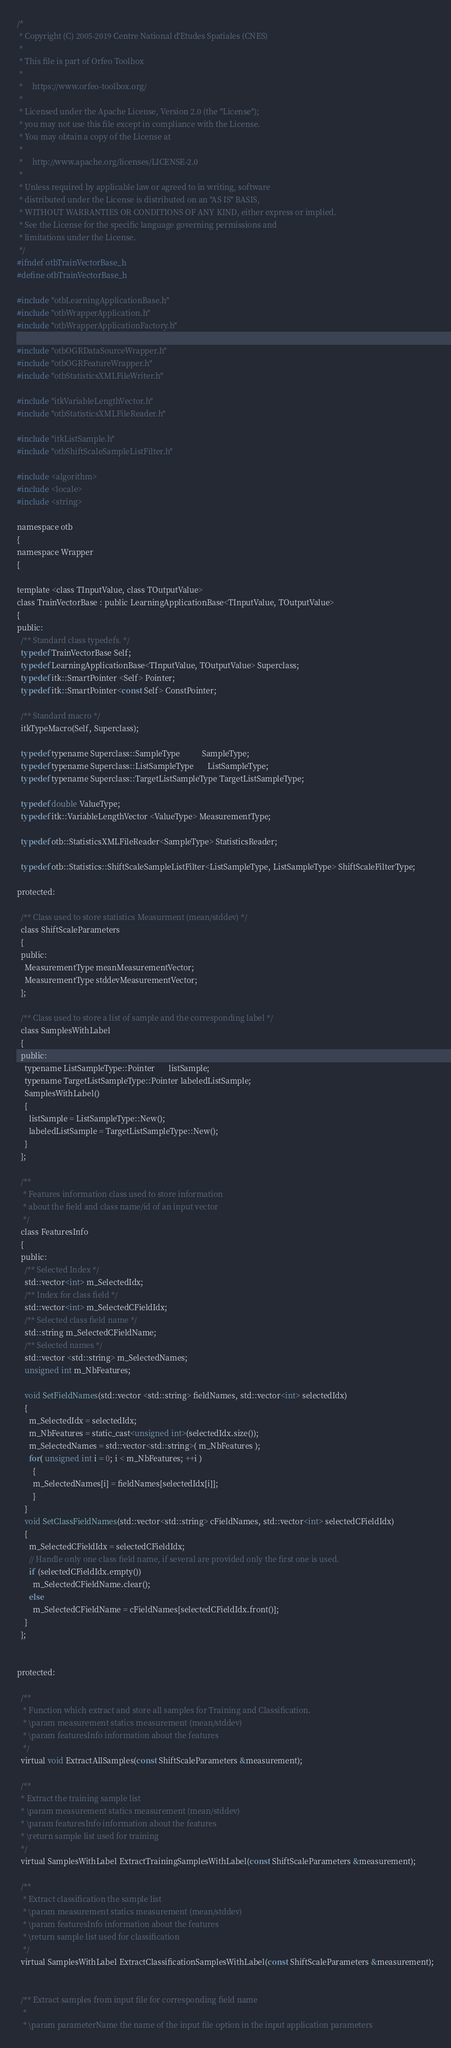Convert code to text. <code><loc_0><loc_0><loc_500><loc_500><_C_>/*
 * Copyright (C) 2005-2019 Centre National d'Etudes Spatiales (CNES)
 *
 * This file is part of Orfeo Toolbox
 *
 *     https://www.orfeo-toolbox.org/
 *
 * Licensed under the Apache License, Version 2.0 (the "License");
 * you may not use this file except in compliance with the License.
 * You may obtain a copy of the License at
 *
 *     http://www.apache.org/licenses/LICENSE-2.0
 *
 * Unless required by applicable law or agreed to in writing, software
 * distributed under the License is distributed on an "AS IS" BASIS,
 * WITHOUT WARRANTIES OR CONDITIONS OF ANY KIND, either express or implied.
 * See the License for the specific language governing permissions and
 * limitations under the License.
 */
#ifndef otbTrainVectorBase_h
#define otbTrainVectorBase_h

#include "otbLearningApplicationBase.h"
#include "otbWrapperApplication.h"
#include "otbWrapperApplicationFactory.h"

#include "otbOGRDataSourceWrapper.h"
#include "otbOGRFeatureWrapper.h"
#include "otbStatisticsXMLFileWriter.h"

#include "itkVariableLengthVector.h"
#include "otbStatisticsXMLFileReader.h"

#include "itkListSample.h"
#include "otbShiftScaleSampleListFilter.h"

#include <algorithm>
#include <locale>
#include <string>

namespace otb
{
namespace Wrapper
{

template <class TInputValue, class TOutputValue>
class TrainVectorBase : public LearningApplicationBase<TInputValue, TOutputValue>
{
public:
  /** Standard class typedefs. */
  typedef TrainVectorBase Self;
  typedef LearningApplicationBase<TInputValue, TOutputValue> Superclass;
  typedef itk::SmartPointer <Self> Pointer;
  typedef itk::SmartPointer<const Self> ConstPointer;

  /** Standard macro */
  itkTypeMacro(Self, Superclass);

  typedef typename Superclass::SampleType           SampleType;
  typedef typename Superclass::ListSampleType       ListSampleType;
  typedef typename Superclass::TargetListSampleType TargetListSampleType;
  
  typedef double ValueType;
  typedef itk::VariableLengthVector <ValueType> MeasurementType;

  typedef otb::StatisticsXMLFileReader<SampleType> StatisticsReader;

  typedef otb::Statistics::ShiftScaleSampleListFilter<ListSampleType, ListSampleType> ShiftScaleFilterType;

protected:

  /** Class used to store statistics Measurment (mean/stddev) */
  class ShiftScaleParameters
  {
  public:
    MeasurementType meanMeasurementVector;
    MeasurementType stddevMeasurementVector;
  };

  /** Class used to store a list of sample and the corresponding label */
  class SamplesWithLabel
  {
  public:
    typename ListSampleType::Pointer       listSample;
    typename TargetListSampleType::Pointer labeledListSample;
    SamplesWithLabel()
    {
      listSample = ListSampleType::New();
      labeledListSample = TargetListSampleType::New();
    }
  };

  /**
   * Features information class used to store information
   * about the field and class name/id of an input vector
   */
  class FeaturesInfo
  {
  public:
    /** Selected Index */
    std::vector<int> m_SelectedIdx;
    /** Index for class field */
    std::vector<int> m_SelectedCFieldIdx;
    /** Selected class field name */
    std::string m_SelectedCFieldName;
    /** Selected names */
    std::vector <std::string> m_SelectedNames;
    unsigned int m_NbFeatures;

    void SetFieldNames(std::vector <std::string> fieldNames, std::vector<int> selectedIdx)
    {
      m_SelectedIdx = selectedIdx;
      m_NbFeatures = static_cast<unsigned int>(selectedIdx.size());
      m_SelectedNames = std::vector<std::string>( m_NbFeatures );
      for( unsigned int i = 0; i < m_NbFeatures; ++i )
        {
        m_SelectedNames[i] = fieldNames[selectedIdx[i]];
        }
    }
    void SetClassFieldNames(std::vector<std::string> cFieldNames, std::vector<int> selectedCFieldIdx)
    {
      m_SelectedCFieldIdx = selectedCFieldIdx;
      // Handle only one class field name, if several are provided only the first one is used.
      if (selectedCFieldIdx.empty())
        m_SelectedCFieldName.clear();
      else
        m_SelectedCFieldName = cFieldNames[selectedCFieldIdx.front()];
    }
  };


protected:

  /**
   * Function which extract and store all samples for Training and Classification.
   * \param measurement statics measurement (mean/stddev)
   * \param featuresInfo information about the features
   */
  virtual void ExtractAllSamples(const ShiftScaleParameters &measurement);

  /**
  * Extract the training sample list
  * \param measurement statics measurement (mean/stddev)
  * \param featuresInfo information about the features
  * \return sample list used for training
  */
  virtual SamplesWithLabel ExtractTrainingSamplesWithLabel(const ShiftScaleParameters &measurement);

  /**
   * Extract classification the sample list
   * \param measurement statics measurement (mean/stddev)
   * \param featuresInfo information about the features
   * \return sample list used for classification
   */
  virtual SamplesWithLabel ExtractClassificationSamplesWithLabel(const ShiftScaleParameters &measurement);


  /** Extract samples from input file for corresponding field name
   *
   * \param parameterName the name of the input file option in the input application parameters</code> 